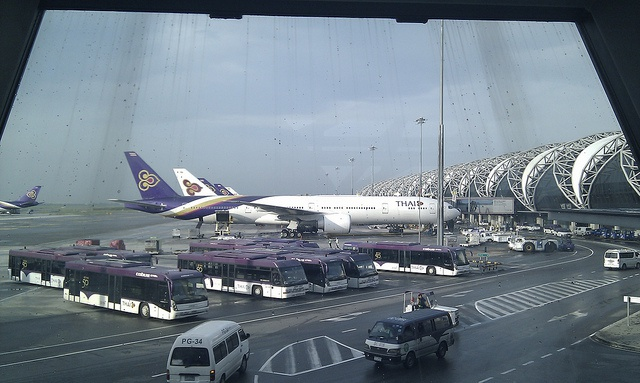Describe the objects in this image and their specific colors. I can see airplane in black, white, gray, and darkgray tones, bus in black, gray, and ivory tones, bus in black, gray, and white tones, car in black, gray, and darkgray tones, and truck in black, gray, and darkblue tones in this image. 